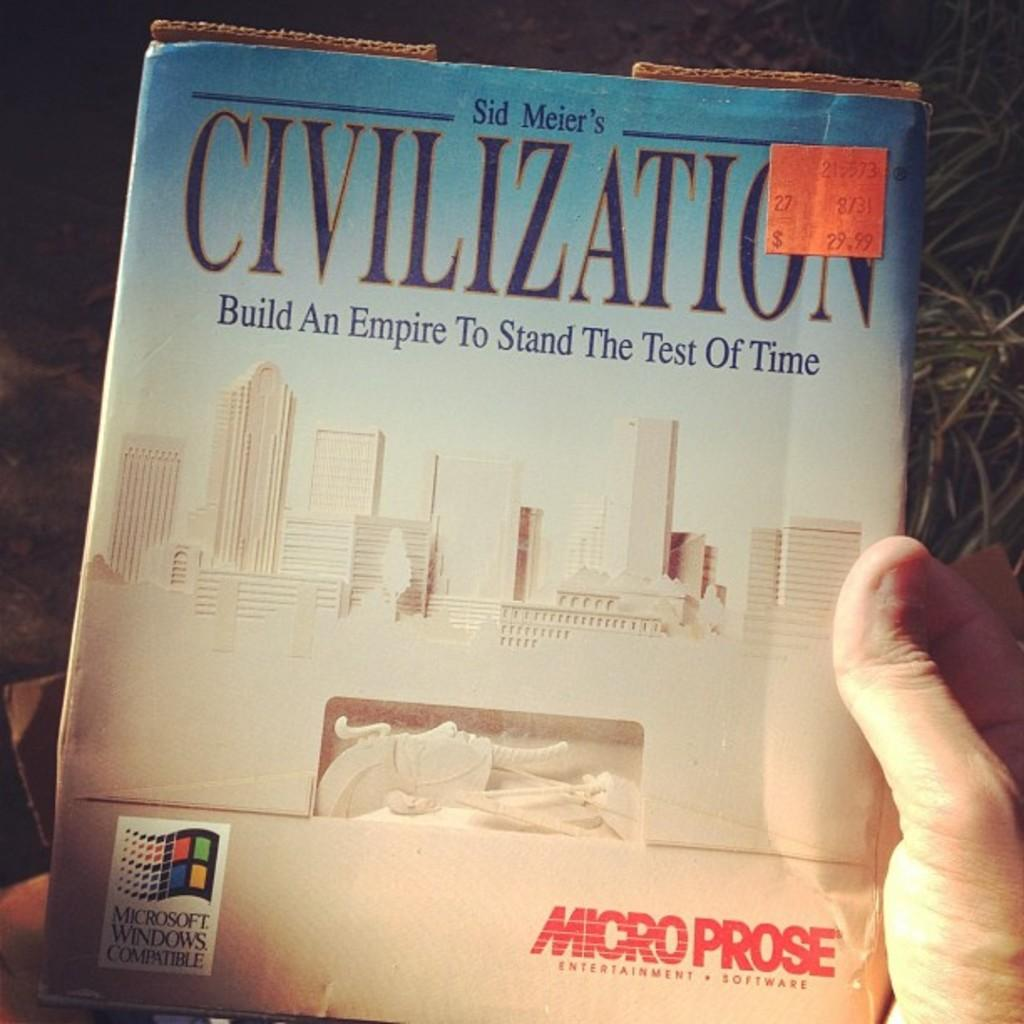<image>
Present a compact description of the photo's key features. Civilization, a game by Sid Meier, is compatible with Microsoft Windows. 